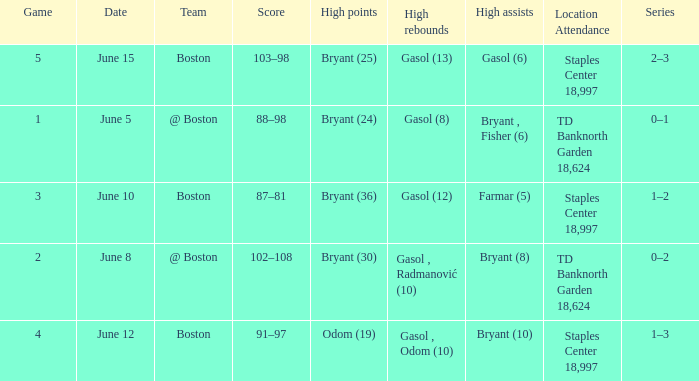Name the series on june 5 0–1. 